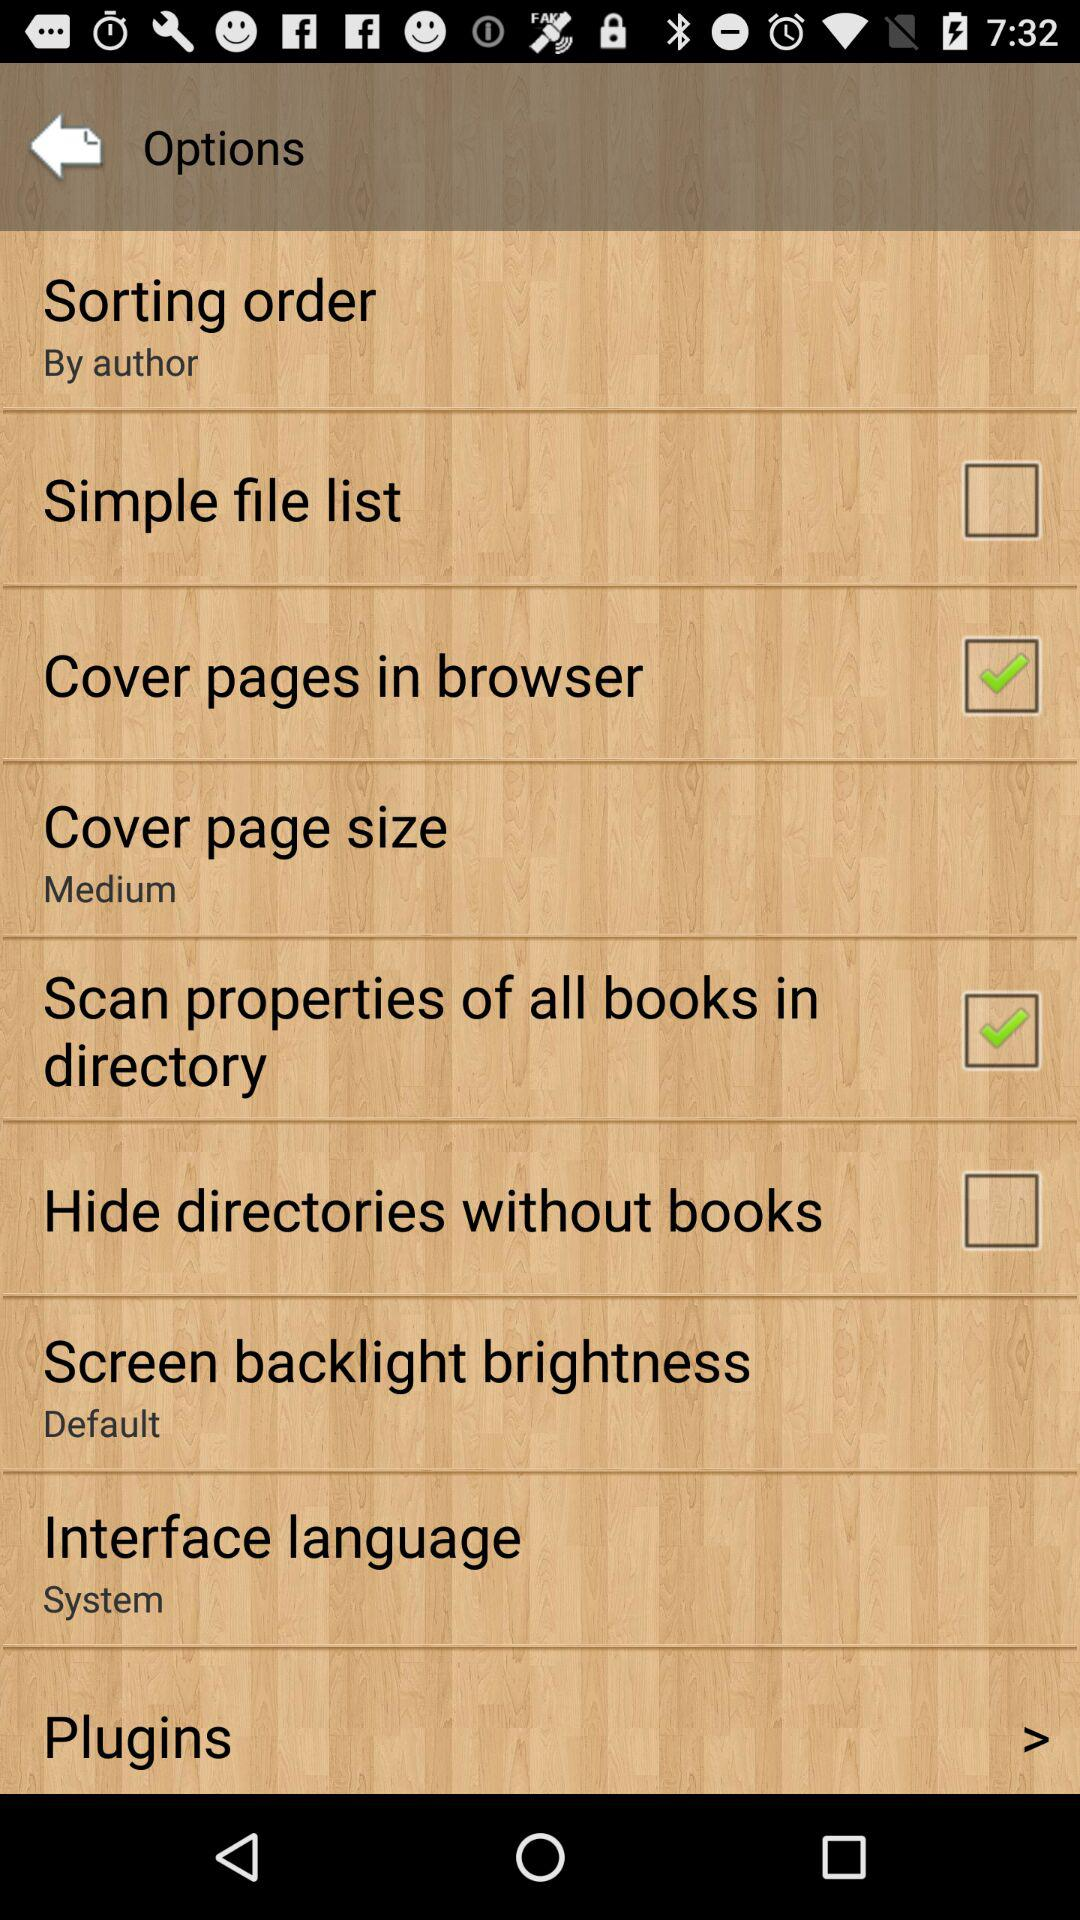What is the cover page size? The cover page size is medium. 